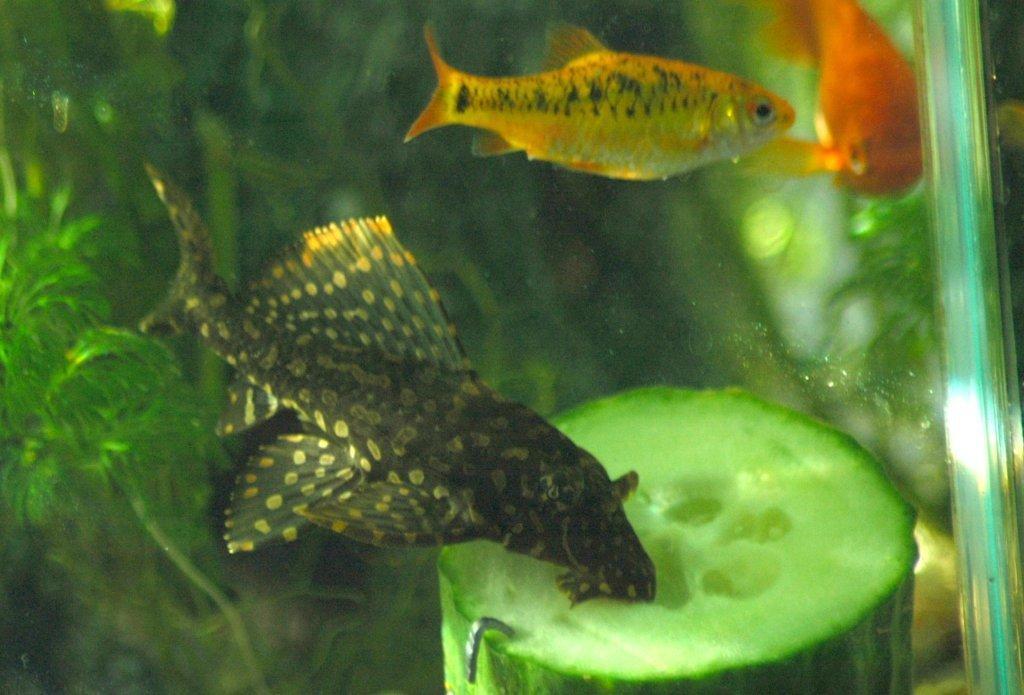In one or two sentences, can you explain what this image depicts? In the foreground of this image, there are fish in the water and we can also see a vegetable at the bottom and an artificial plant in the background. 